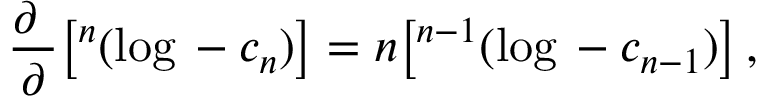Convert formula to latex. <formula><loc_0><loc_0><loc_500><loc_500>\frac { \partial } { \partial \L } \left [ \L ^ { n } ( \log \L - c _ { n } ) \right ] = n \left [ \L ^ { n - 1 } ( \log \L - c _ { n - 1 } ) \right ] \, ,</formula> 